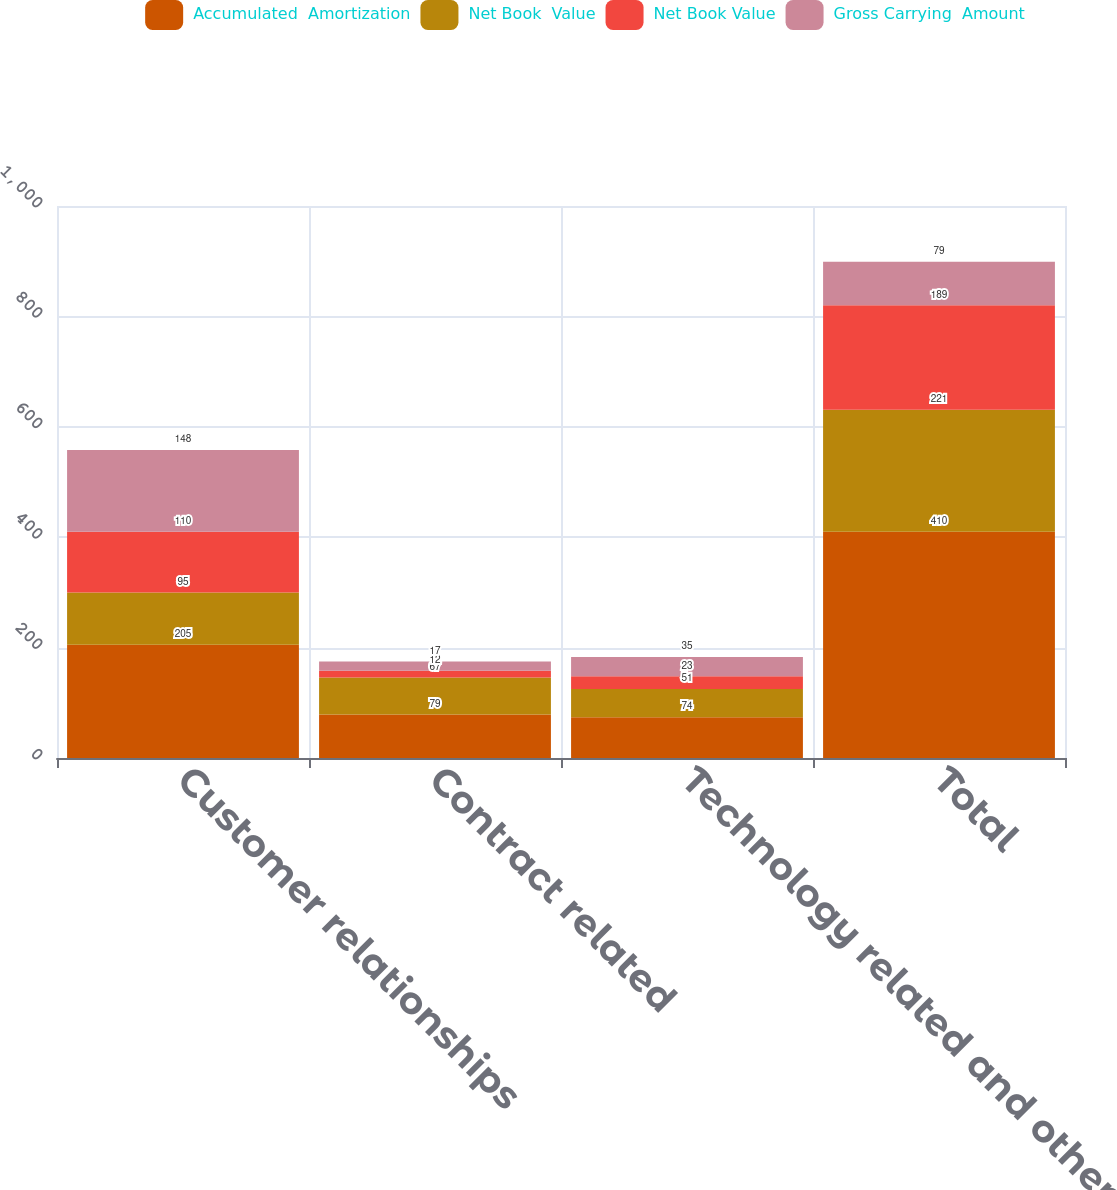<chart> <loc_0><loc_0><loc_500><loc_500><stacked_bar_chart><ecel><fcel>Customer relationships<fcel>Contract related<fcel>Technology related and other<fcel>Total<nl><fcel>Accumulated  Amortization<fcel>205<fcel>79<fcel>74<fcel>410<nl><fcel>Net Book  Value<fcel>95<fcel>67<fcel>51<fcel>221<nl><fcel>Net Book Value<fcel>110<fcel>12<fcel>23<fcel>189<nl><fcel>Gross Carrying  Amount<fcel>148<fcel>17<fcel>35<fcel>79<nl></chart> 